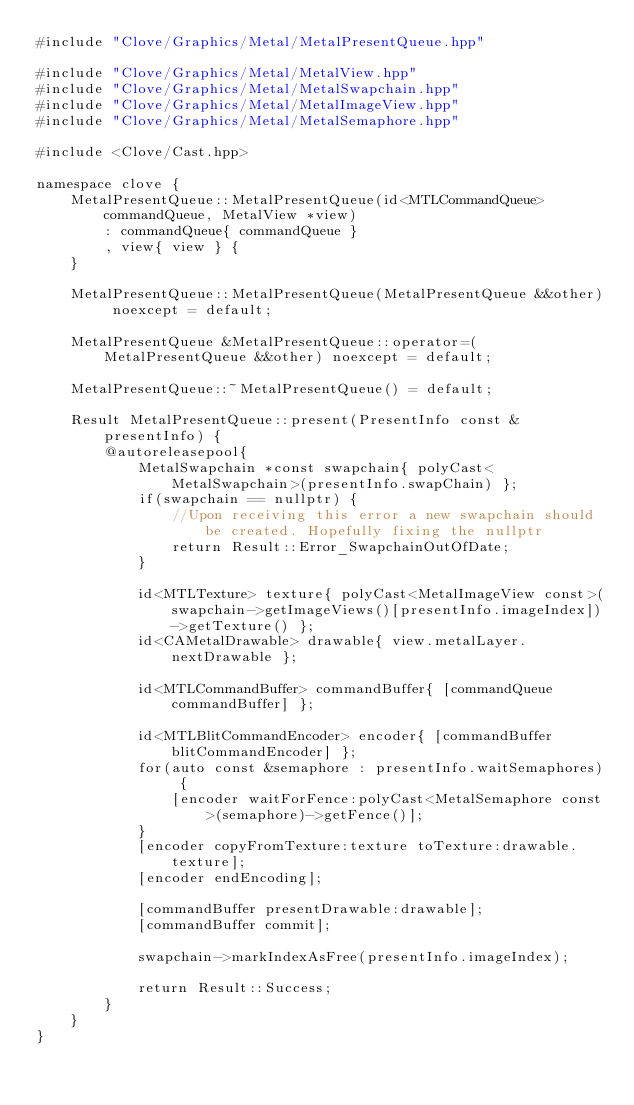<code> <loc_0><loc_0><loc_500><loc_500><_ObjectiveC_>#include "Clove/Graphics/Metal/MetalPresentQueue.hpp"

#include "Clove/Graphics/Metal/MetalView.hpp"
#include "Clove/Graphics/Metal/MetalSwapchain.hpp"
#include "Clove/Graphics/Metal/MetalImageView.hpp"
#include "Clove/Graphics/Metal/MetalSemaphore.hpp"

#include <Clove/Cast.hpp>

namespace clove {
    MetalPresentQueue::MetalPresentQueue(id<MTLCommandQueue> commandQueue, MetalView *view)
        : commandQueue{ commandQueue }
        , view{ view } {
    }
    
    MetalPresentQueue::MetalPresentQueue(MetalPresentQueue &&other) noexcept = default;
    
    MetalPresentQueue &MetalPresentQueue::operator=(MetalPresentQueue &&other) noexcept = default;
    
    MetalPresentQueue::~MetalPresentQueue() = default;
    
    Result MetalPresentQueue::present(PresentInfo const &presentInfo) {
        @autoreleasepool{
            MetalSwapchain *const swapchain{ polyCast<MetalSwapchain>(presentInfo.swapChain) };
            if(swapchain == nullptr) {
                //Upon receiving this error a new swapchain should be created. Hopefully fixing the nullptr
                return Result::Error_SwapchainOutOfDate;
            }
            
            id<MTLTexture> texture{ polyCast<MetalImageView const>(swapchain->getImageViews()[presentInfo.imageIndex])->getTexture() };
            id<CAMetalDrawable> drawable{ view.metalLayer.nextDrawable };
            
            id<MTLCommandBuffer> commandBuffer{ [commandQueue commandBuffer] };
            
            id<MTLBlitCommandEncoder> encoder{ [commandBuffer blitCommandEncoder] };
            for(auto const &semaphore : presentInfo.waitSemaphores) {
                [encoder waitForFence:polyCast<MetalSemaphore const>(semaphore)->getFence()];
            }
            [encoder copyFromTexture:texture toTexture:drawable.texture];
            [encoder endEncoding];
            
            [commandBuffer presentDrawable:drawable];
            [commandBuffer commit];
            
            swapchain->markIndexAsFree(presentInfo.imageIndex);
            
            return Result::Success;
        }
    }
}
</code> 